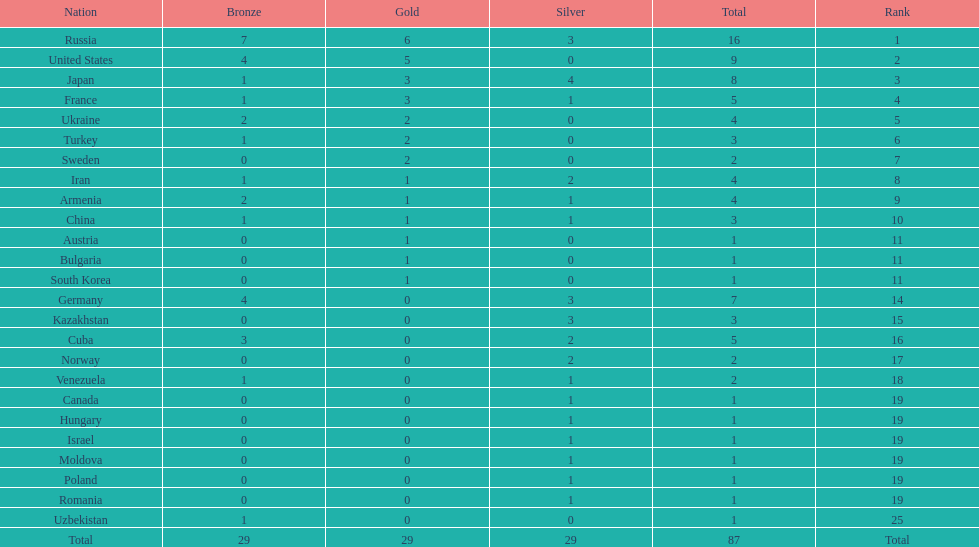Parse the table in full. {'header': ['Nation', 'Bronze', 'Gold', 'Silver', 'Total', 'Rank'], 'rows': [['Russia', '7', '6', '3', '16', '1'], ['United States', '4', '5', '0', '9', '2'], ['Japan', '1', '3', '4', '8', '3'], ['France', '1', '3', '1', '5', '4'], ['Ukraine', '2', '2', '0', '4', '5'], ['Turkey', '1', '2', '0', '3', '6'], ['Sweden', '0', '2', '0', '2', '7'], ['Iran', '1', '1', '2', '4', '8'], ['Armenia', '2', '1', '1', '4', '9'], ['China', '1', '1', '1', '3', '10'], ['Austria', '0', '1', '0', '1', '11'], ['Bulgaria', '0', '1', '0', '1', '11'], ['South Korea', '0', '1', '0', '1', '11'], ['Germany', '4', '0', '3', '7', '14'], ['Kazakhstan', '0', '0', '3', '3', '15'], ['Cuba', '3', '0', '2', '5', '16'], ['Norway', '0', '0', '2', '2', '17'], ['Venezuela', '1', '0', '1', '2', '18'], ['Canada', '0', '0', '1', '1', '19'], ['Hungary', '0', '0', '1', '1', '19'], ['Israel', '0', '0', '1', '1', '19'], ['Moldova', '0', '0', '1', '1', '19'], ['Poland', '0', '0', '1', '1', '19'], ['Romania', '0', '0', '1', '1', '19'], ['Uzbekistan', '1', '0', '0', '1', '25'], ['Total', '29', '29', '29', '87', 'Total']]} Who ranked right after turkey? Sweden. 